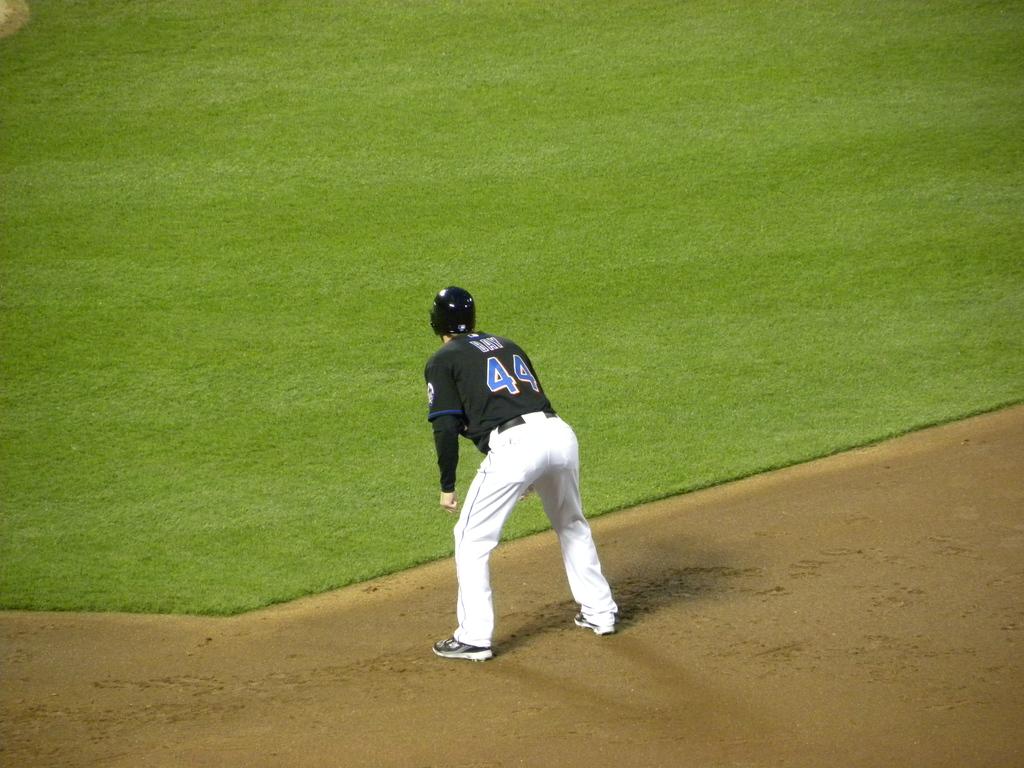Who is out there playing?
Your response must be concise. Bay. What is number of the jersey?
Provide a short and direct response. 44. 